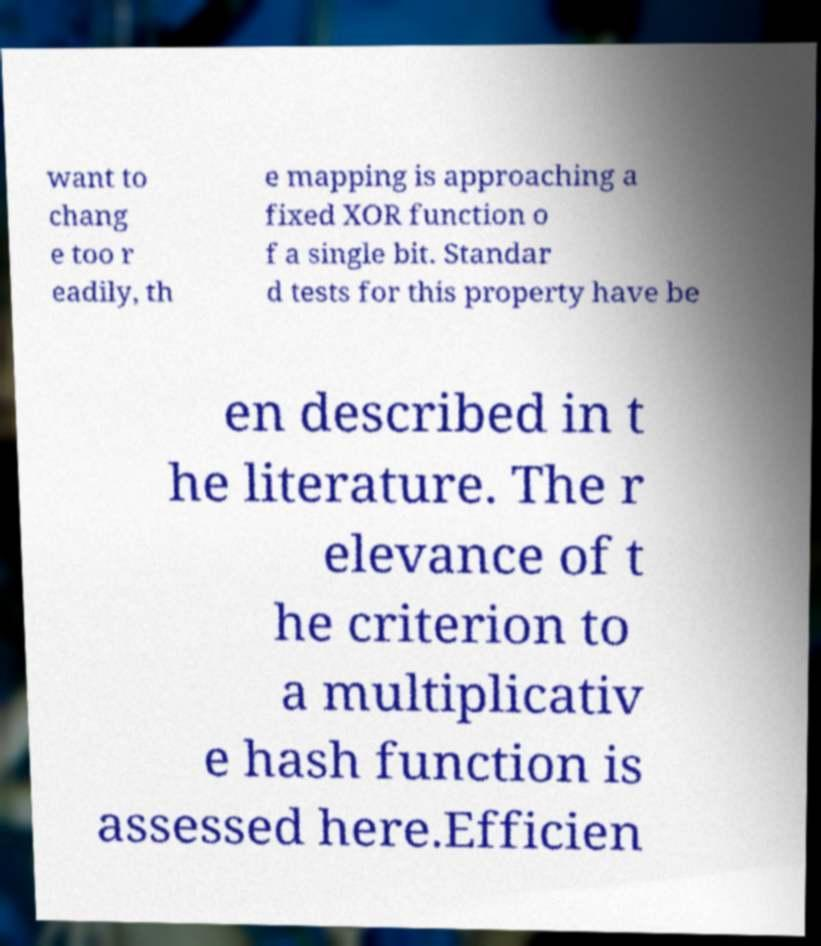I need the written content from this picture converted into text. Can you do that? want to chang e too r eadily, th e mapping is approaching a fixed XOR function o f a single bit. Standar d tests for this property have be en described in t he literature. The r elevance of t he criterion to a multiplicativ e hash function is assessed here.Efficien 